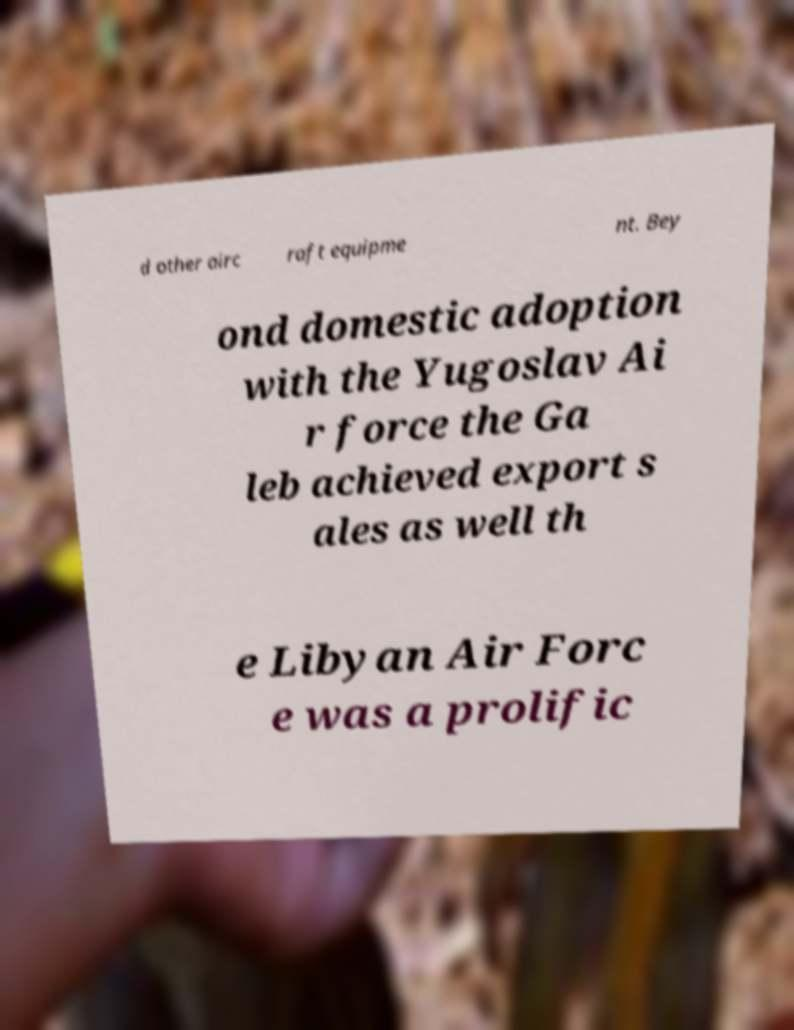Could you extract and type out the text from this image? d other airc raft equipme nt. Bey ond domestic adoption with the Yugoslav Ai r force the Ga leb achieved export s ales as well th e Libyan Air Forc e was a prolific 